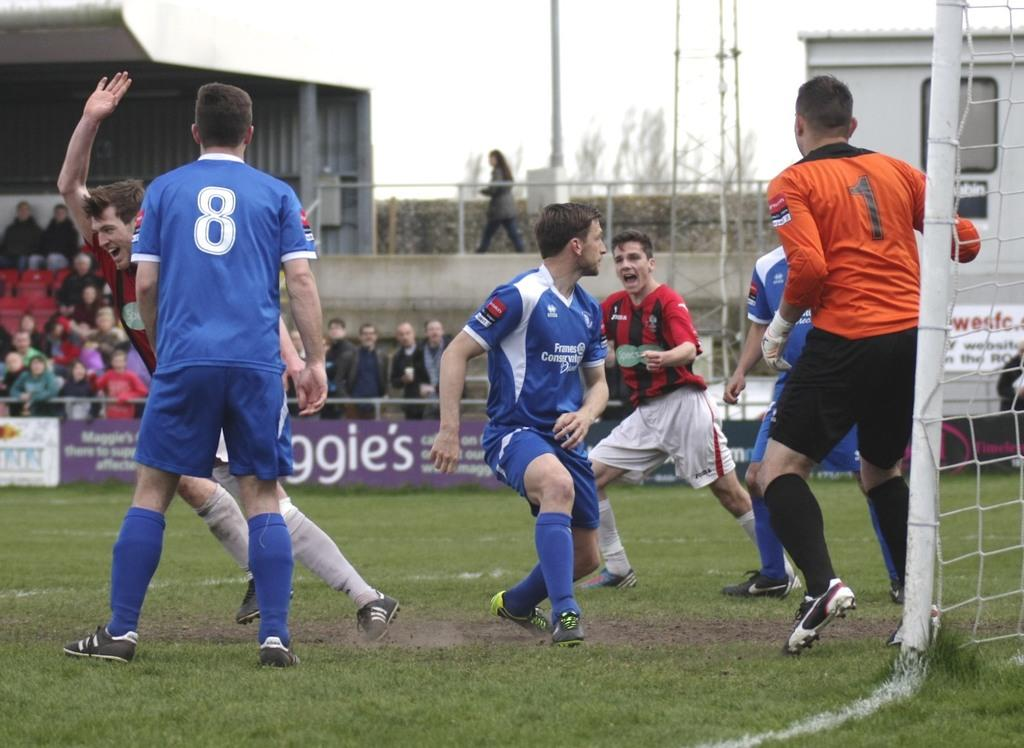<image>
Write a terse but informative summary of the picture. some soccer players with one having the number 1 on 